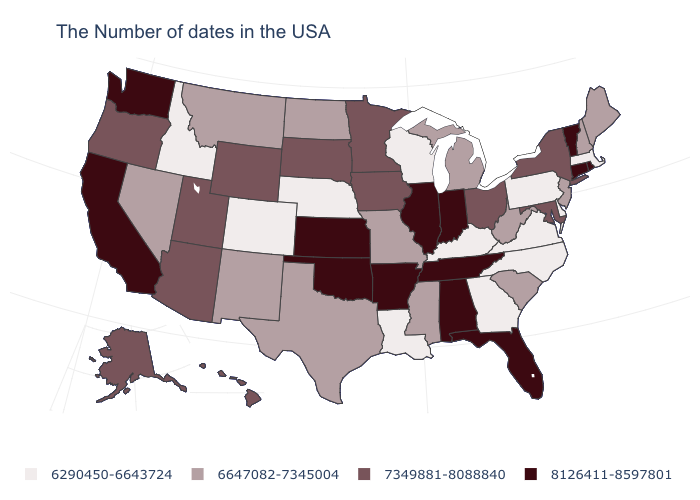Name the states that have a value in the range 6290450-6643724?
Give a very brief answer. Massachusetts, Delaware, Pennsylvania, Virginia, North Carolina, Georgia, Kentucky, Wisconsin, Louisiana, Nebraska, Colorado, Idaho. What is the value of Illinois?
Write a very short answer. 8126411-8597801. What is the highest value in the West ?
Answer briefly. 8126411-8597801. Which states have the highest value in the USA?
Keep it brief. Rhode Island, Vermont, Connecticut, Florida, Indiana, Alabama, Tennessee, Illinois, Arkansas, Kansas, Oklahoma, California, Washington. Name the states that have a value in the range 7349881-8088840?
Answer briefly. New York, Maryland, Ohio, Minnesota, Iowa, South Dakota, Wyoming, Utah, Arizona, Oregon, Alaska, Hawaii. Does Illinois have the lowest value in the MidWest?
Give a very brief answer. No. Name the states that have a value in the range 6290450-6643724?
Write a very short answer. Massachusetts, Delaware, Pennsylvania, Virginia, North Carolina, Georgia, Kentucky, Wisconsin, Louisiana, Nebraska, Colorado, Idaho. Name the states that have a value in the range 6290450-6643724?
Answer briefly. Massachusetts, Delaware, Pennsylvania, Virginia, North Carolina, Georgia, Kentucky, Wisconsin, Louisiana, Nebraska, Colorado, Idaho. What is the value of Nebraska?
Be succinct. 6290450-6643724. What is the value of Mississippi?
Quick response, please. 6647082-7345004. Does the map have missing data?
Write a very short answer. No. What is the lowest value in states that border Arizona?
Be succinct. 6290450-6643724. Does Kansas have the highest value in the USA?
Be succinct. Yes. What is the highest value in the USA?
Quick response, please. 8126411-8597801. Does Washington have a higher value than Iowa?
Answer briefly. Yes. 